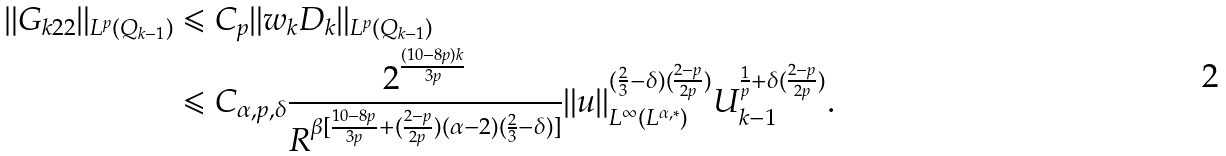Convert formula to latex. <formula><loc_0><loc_0><loc_500><loc_500>\| G _ { k 2 2 } \| _ { L ^ { p } ( Q _ { k - 1 } ) } & \leqslant C _ { p } \| w _ { k } D _ { k } \| _ { L ^ { p } ( Q _ { k - 1 } ) } \\ & \leqslant C _ { \alpha , p , \delta } \frac { 2 ^ { \frac { ( 1 0 - 8 p ) k } { 3 p } } } { R ^ { \beta [ \frac { 1 0 - 8 p } { 3 p } + ( \frac { 2 - p } { 2 p } ) ( \alpha - 2 ) ( \frac { 2 } { 3 } - \delta ) ] } } \| u \| _ { L ^ { \infty } ( L ^ { \alpha , * } ) } ^ { ( \frac { 2 } { 3 } - \delta ) ( \frac { 2 - p } { 2 p } ) } U _ { k - 1 } ^ { \frac { 1 } { p } + \delta ( \frac { 2 - p } { 2 p } ) } .</formula> 